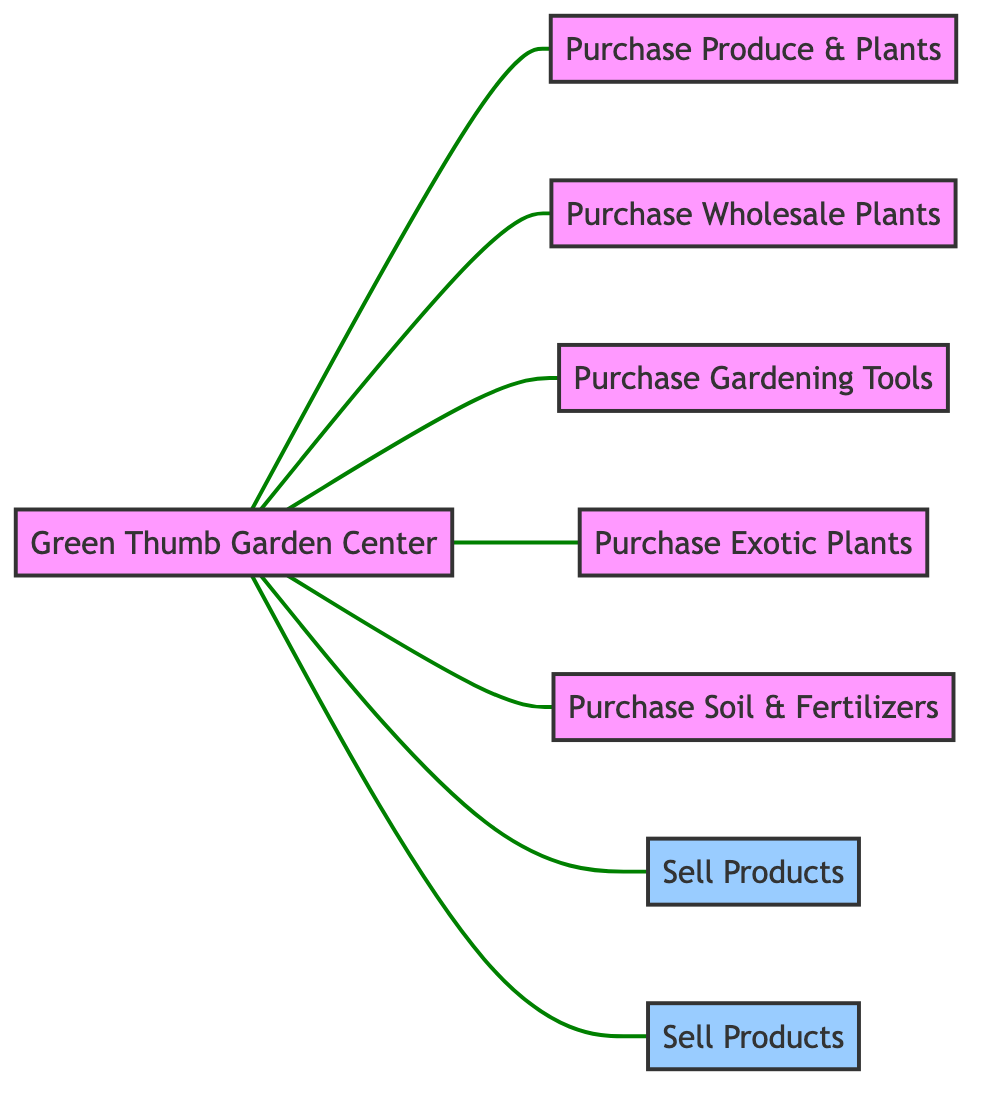What are the types of customers for the garden center? The garden center has two identified customer types: Residential Customers and Commercial Clients. This information can be found by looking at the connections from the Garden Center node to the respective customer nodes.
Answer: Residential Customers, Commercial Clients How many suppliers does the garden center have? By counting the nodes connected to the Garden Center that represent suppliers, we identify Sunny Fields Farm, Evergreen Wholesale Nursery, Gardener's Tool Depot, Exotic Plant Importers Ltd., and Rich Earth Soil Suppliers. There are a total of five suppliers.
Answer: 5 What product does the garden center purchase from the Tool Supplier? The labeled relationship between the Garden Center and the Tool Supplier indicates that the garden center purchases Gardening Tools from this supplier. We find this by examining the edge that connects the two nodes.
Answer: Gardening Tools Which node is connected to the Garden Center and represents the purchase of Exotic Plants? The connection to the Plant Importer node indicates that the garden center purchases Exotic Plants from this supplier. This can be determined by looking at the edge connecting Garden Center and Plant Importer.
Answer: Exotic Plants How many edges are connected to the Garden Center? Counting all the edges that connect to the Garden Center node, we find the total is seven: five for suppliers and two for customers, indicating they have multiple relationships.
Answer: 7 What does the edge between Garden Center and Sunny Fields Farm represent? The relationship labeled on the edge connecting Garden Center and Sunny Fields Farm indicates that the garden center purchases Produce & Plants from this local farm. This can be validated by inspecting the specific edge in the diagram.
Answer: Purchase Produce & Plants Which supplier is solely focused on providing soil-related products? The Soil Supplier node is specifically dedicated to providing soil and fertilizers to the garden center, which is evident from the connection specifying the purchase of these items.
Answer: Rich Earth Soil Suppliers Besides purchasing, who else does the Garden Center sell products to? The Garden Center sells products to both Residential Customers and Commercial Clients, making it evident that they serve different market segments. This is reflected in the two connections leading to these customers.
Answer: Residential Customers, Commercial Clients 